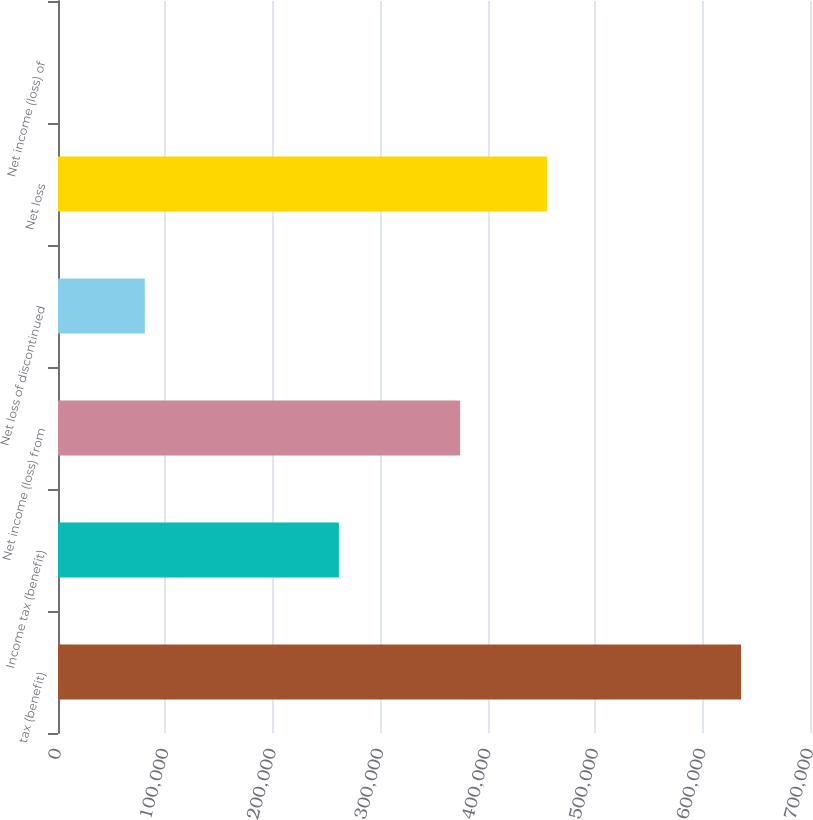Convert chart. <chart><loc_0><loc_0><loc_500><loc_500><bar_chart><fcel>tax (benefit)<fcel>Income tax (benefit)<fcel>Net income (loss) from<fcel>Net loss of discontinued<fcel>Net loss<fcel>Net income (loss) of<nl><fcel>635798<fcel>261461<fcel>374337<fcel>80800<fcel>455136<fcel>1.16<nl></chart> 